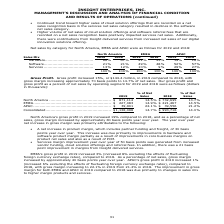According to Insight Enterprises's financial document, How much did Gross profit increased in 2019 compared to 2018? According to the financial document, $144.4 million. The relevant text states: "Gross Profit . Gross profit increased 15%, or $144.4 million, in 2019 compared to 2018, with gross margin increasing approximately 70 basis points to 14.7% of n..." Also, How much did North America's Gross profit increased in 2019 compared to 2018? According to the financial document, 19%. The relevant text states: ".................................. 66% 67% 41% 43% 19% 16% Software........................................ 21% 21% 49% 48% 52% 57% Services ................." Also, How much did EMEA's Gross profit increased in 2019 compared to 2018? According to the financial document, 3%. The relevant text states: ".................................... 66% 67% 41% 43% 19% 16% Software........................................ 21% 21% 49% 48% 52% 57% Services ............." Also, can you calculate: What is the change in Net sales of North America between 2018 and 2019? Based on the calculation: 871,114-732,695, the result is 138419 (in thousands). This is based on the information: "............................................... $ 871,114 14.5% $ 732,695 13.7% EMEA............................................................... $ 227,083 ............................... $ 871,114 ..." The key data points involved are: 732,695, 871,114. Also, can you calculate: What is the change in Net sales of EMEA between 2018 and 2019? Based on the calculation: 227,083-221,467, the result is 5616 (in thousands). This is based on the information: "............................................... $ 227,083 14.9% $ 221,467 14.5% APAC ............................................................... $ 39,901 ............................... $ 227,083 ..." The key data points involved are: 221,467, 227,083. Also, can you calculate: What is the average Net sales of North America for 2018 and 2019? To answer this question, I need to perform calculations using the financial data. The calculation is: (871,114+732,695) / 2, which equals 801904.5 (in thousands). This is based on the information: "............................................... $ 871,114 14.5% $ 732,695 13.7% EMEA............................................................... $ 227,083 ............................... $ 871,114 ..." The key data points involved are: 732,695, 871,114. 